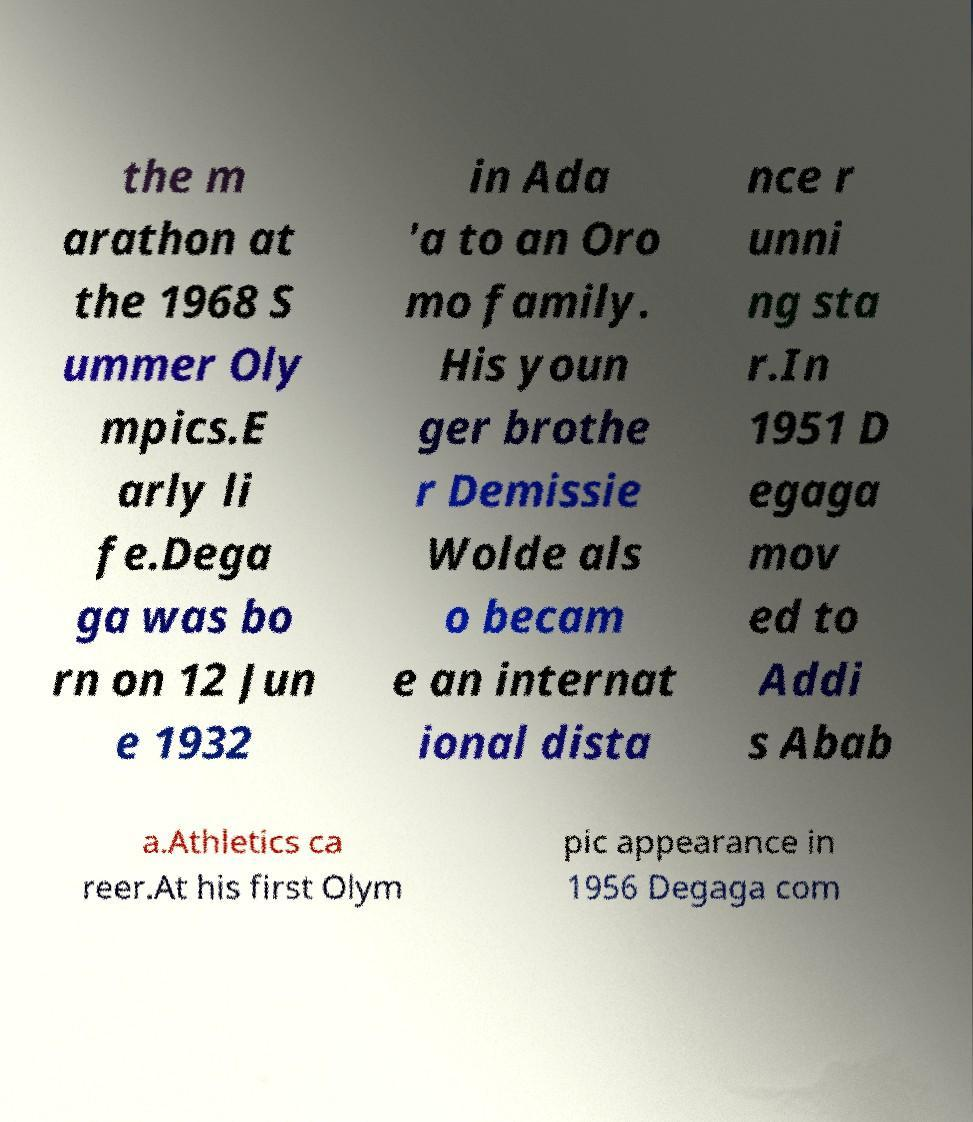Can you accurately transcribe the text from the provided image for me? the m arathon at the 1968 S ummer Oly mpics.E arly li fe.Dega ga was bo rn on 12 Jun e 1932 in Ada 'a to an Oro mo family. His youn ger brothe r Demissie Wolde als o becam e an internat ional dista nce r unni ng sta r.In 1951 D egaga mov ed to Addi s Abab a.Athletics ca reer.At his first Olym pic appearance in 1956 Degaga com 